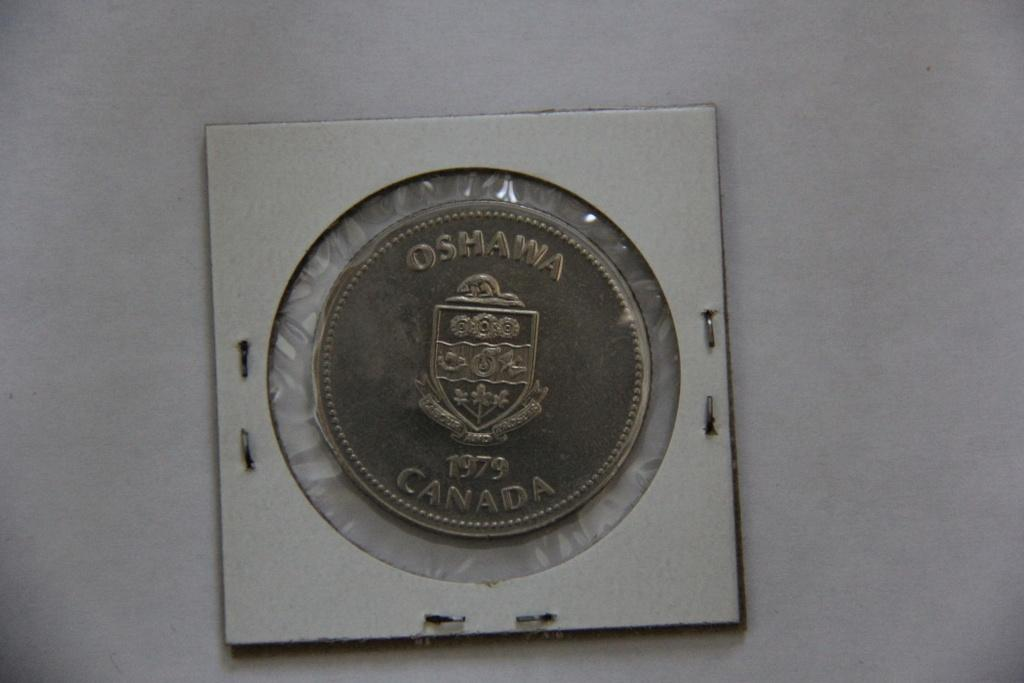Provide a one-sentence caption for the provided image. A coin stamped with Canada and 1979 is encased in plastic. 